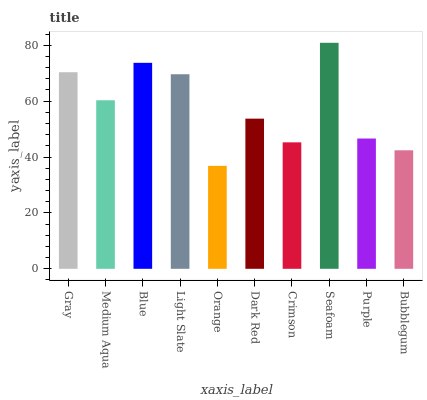Is Orange the minimum?
Answer yes or no. Yes. Is Seafoam the maximum?
Answer yes or no. Yes. Is Medium Aqua the minimum?
Answer yes or no. No. Is Medium Aqua the maximum?
Answer yes or no. No. Is Gray greater than Medium Aqua?
Answer yes or no. Yes. Is Medium Aqua less than Gray?
Answer yes or no. Yes. Is Medium Aqua greater than Gray?
Answer yes or no. No. Is Gray less than Medium Aqua?
Answer yes or no. No. Is Medium Aqua the high median?
Answer yes or no. Yes. Is Dark Red the low median?
Answer yes or no. Yes. Is Gray the high median?
Answer yes or no. No. Is Purple the low median?
Answer yes or no. No. 